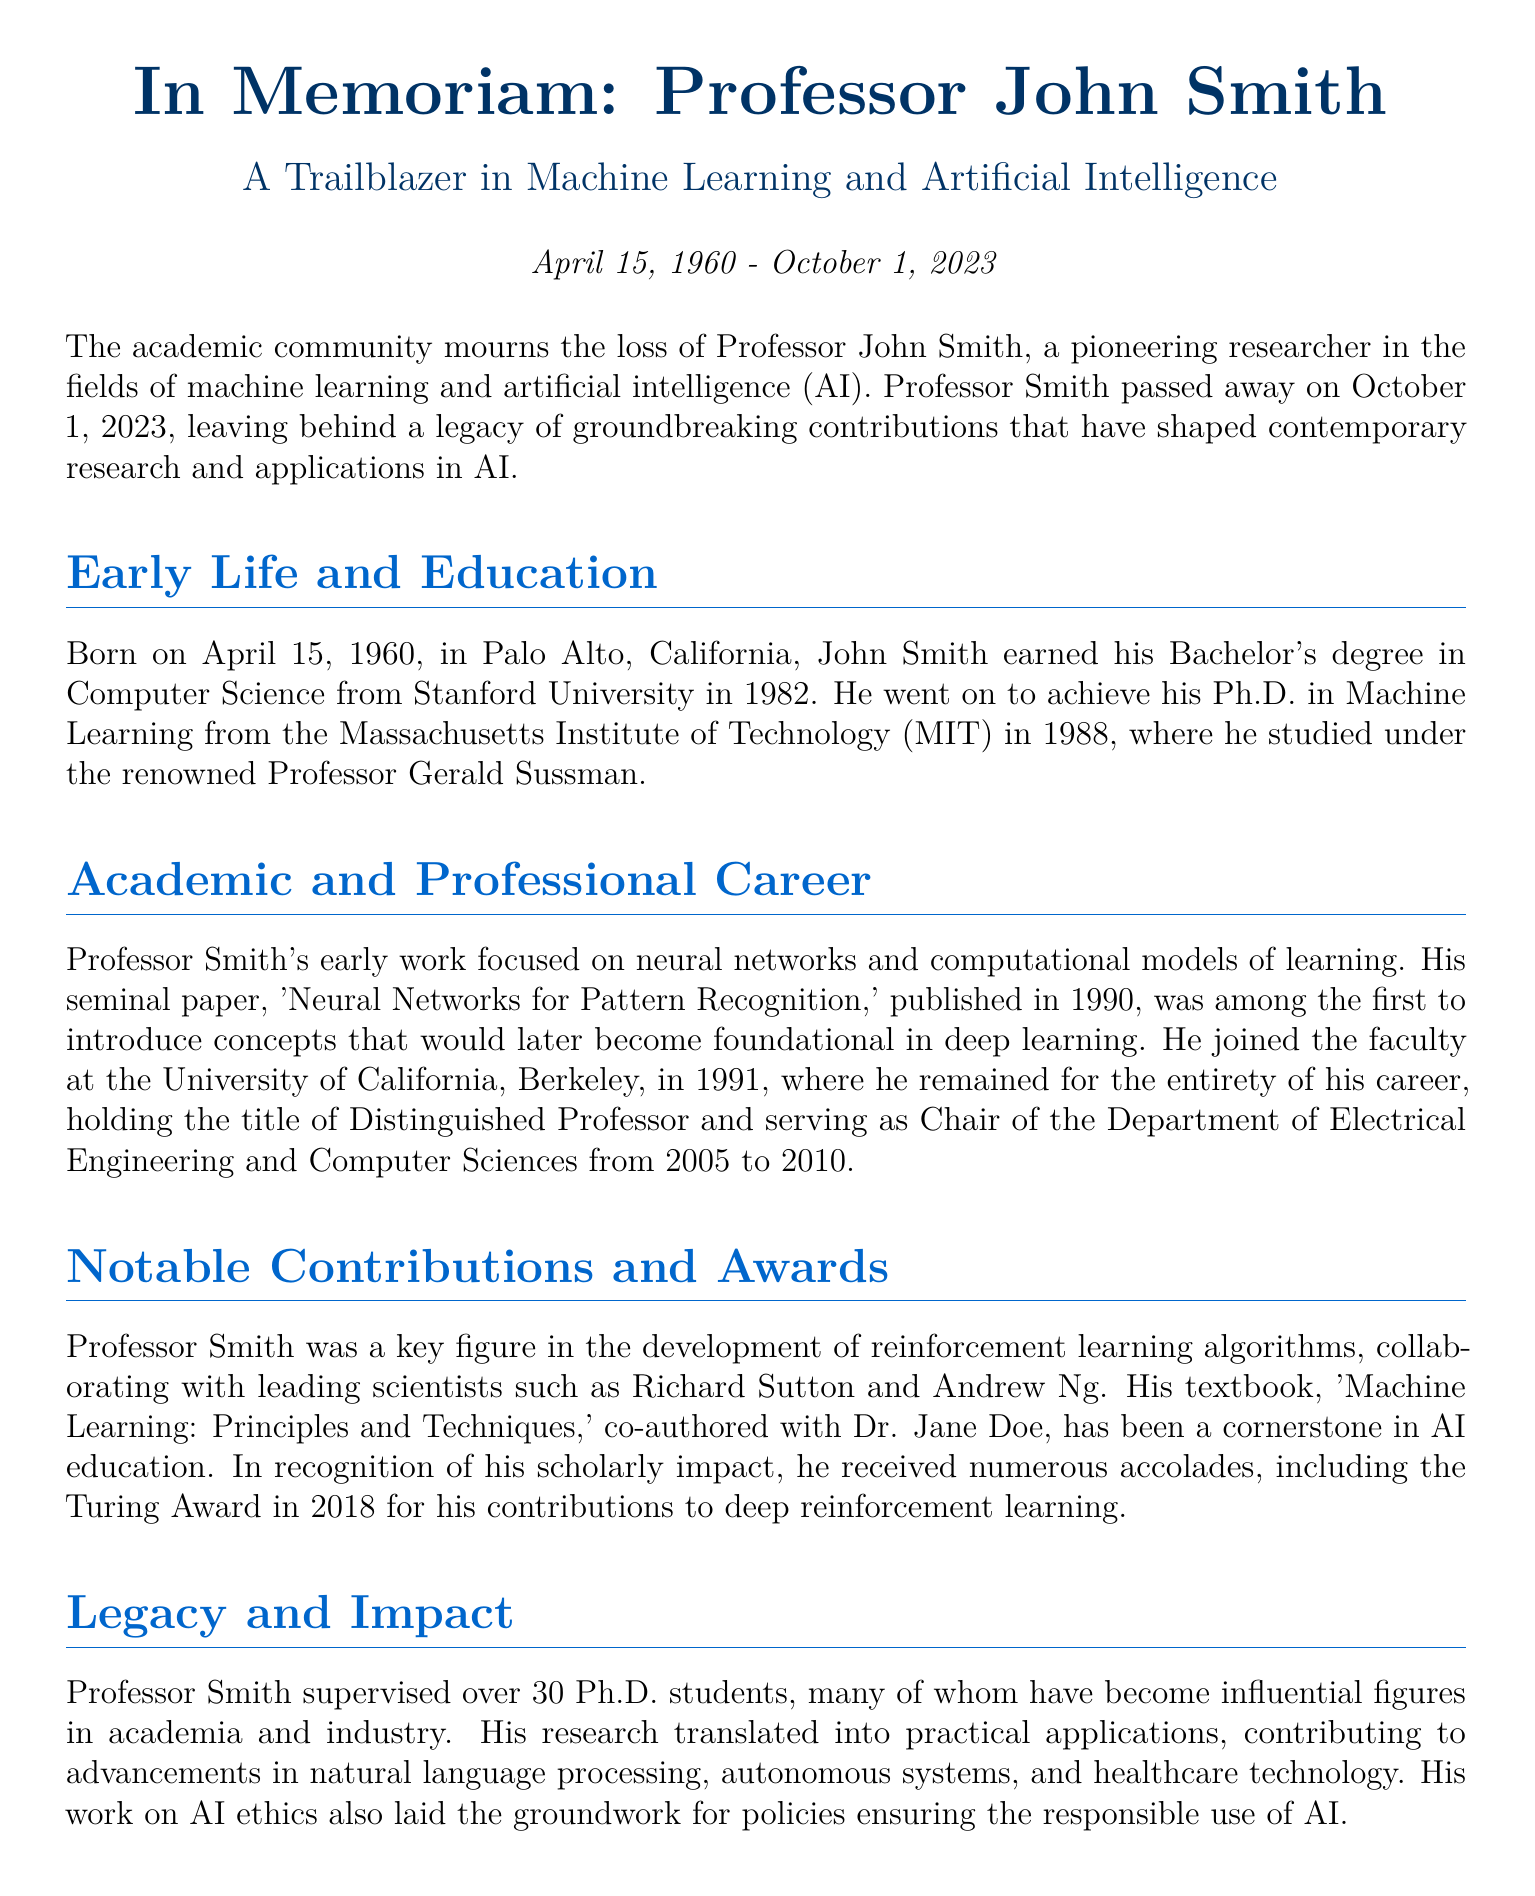What is Professor John Smith's birth date? The document states that he was born on April 15, 1960.
Answer: April 15, 1960 When did Professor Smith receive his Ph.D.? The document mentions that he achieved his Ph.D. in 1988.
Answer: 1988 Which university did Professor Smith join in 1991? The document indicates that he joined the University of California, Berkeley.
Answer: University of California, Berkeley What award did Professor Smith receive in 2018? The document states that he received the Turing Award in 2018.
Answer: Turing Award How many Ph.D. students did Professor Smith supervise? The document mentions that he supervised over 30 Ph.D. students.
Answer: Over 30 What was a key focus of Professor Smith's early work? The document notes that his early work focused on neural networks and computational models of learning.
Answer: Neural networks What role did Professor Smith hold from 2005 to 2010? The document states he served as Chair of the Department of Electrical Engineering and Computer Sciences during that period.
Answer: Chair What was one of the contributions in AI ethics mentioned? The document indicates his work laid the groundwork for policies ensuring responsible use of AI.
Answer: Responsible use of AI What was one of Professor Smith's hobbies? The document mentions he was known for his love of classical music and was an accomplished pianist.
Answer: Classical music 